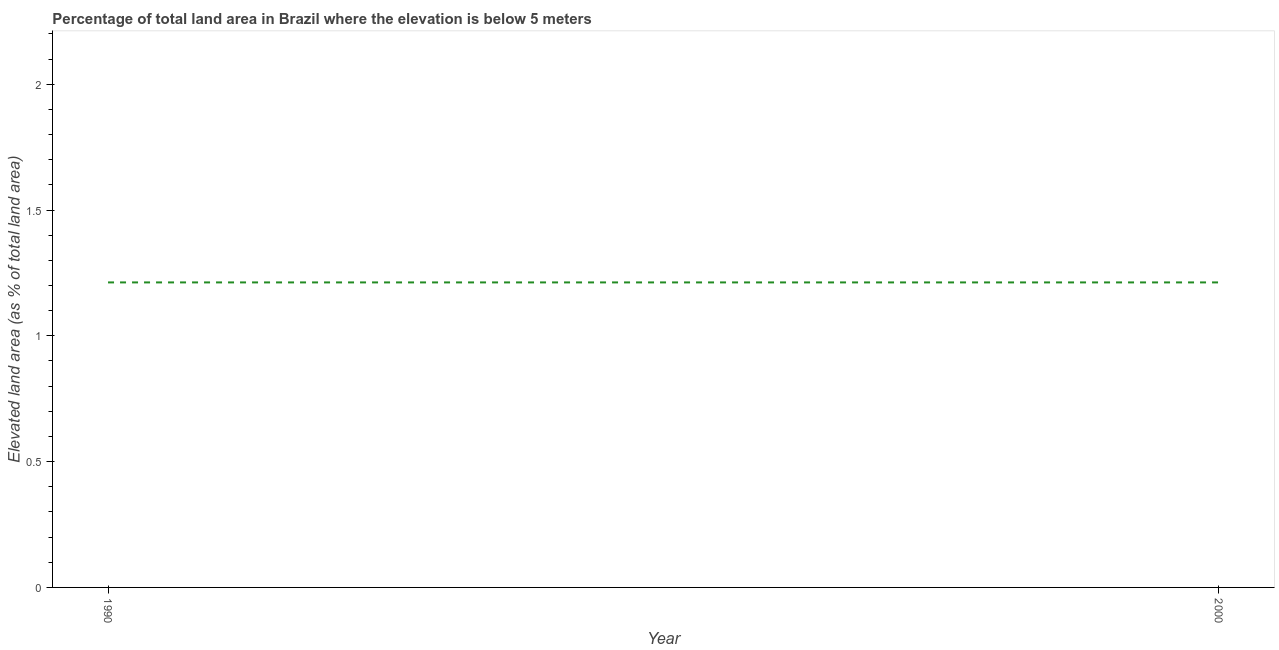What is the total elevated land area in 1990?
Your response must be concise. 1.21. Across all years, what is the maximum total elevated land area?
Your answer should be very brief. 1.21. Across all years, what is the minimum total elevated land area?
Provide a short and direct response. 1.21. In which year was the total elevated land area maximum?
Make the answer very short. 1990. What is the sum of the total elevated land area?
Offer a very short reply. 2.42. What is the difference between the total elevated land area in 1990 and 2000?
Your answer should be very brief. 0. What is the average total elevated land area per year?
Offer a terse response. 1.21. What is the median total elevated land area?
Offer a terse response. 1.21. What is the ratio of the total elevated land area in 1990 to that in 2000?
Offer a very short reply. 1. Does the total elevated land area monotonically increase over the years?
Keep it short and to the point. No. How many lines are there?
Offer a terse response. 1. How many years are there in the graph?
Ensure brevity in your answer.  2. What is the difference between two consecutive major ticks on the Y-axis?
Your answer should be compact. 0.5. Are the values on the major ticks of Y-axis written in scientific E-notation?
Your response must be concise. No. What is the title of the graph?
Make the answer very short. Percentage of total land area in Brazil where the elevation is below 5 meters. What is the label or title of the Y-axis?
Offer a terse response. Elevated land area (as % of total land area). What is the Elevated land area (as % of total land area) of 1990?
Provide a short and direct response. 1.21. What is the Elevated land area (as % of total land area) in 2000?
Provide a short and direct response. 1.21. 